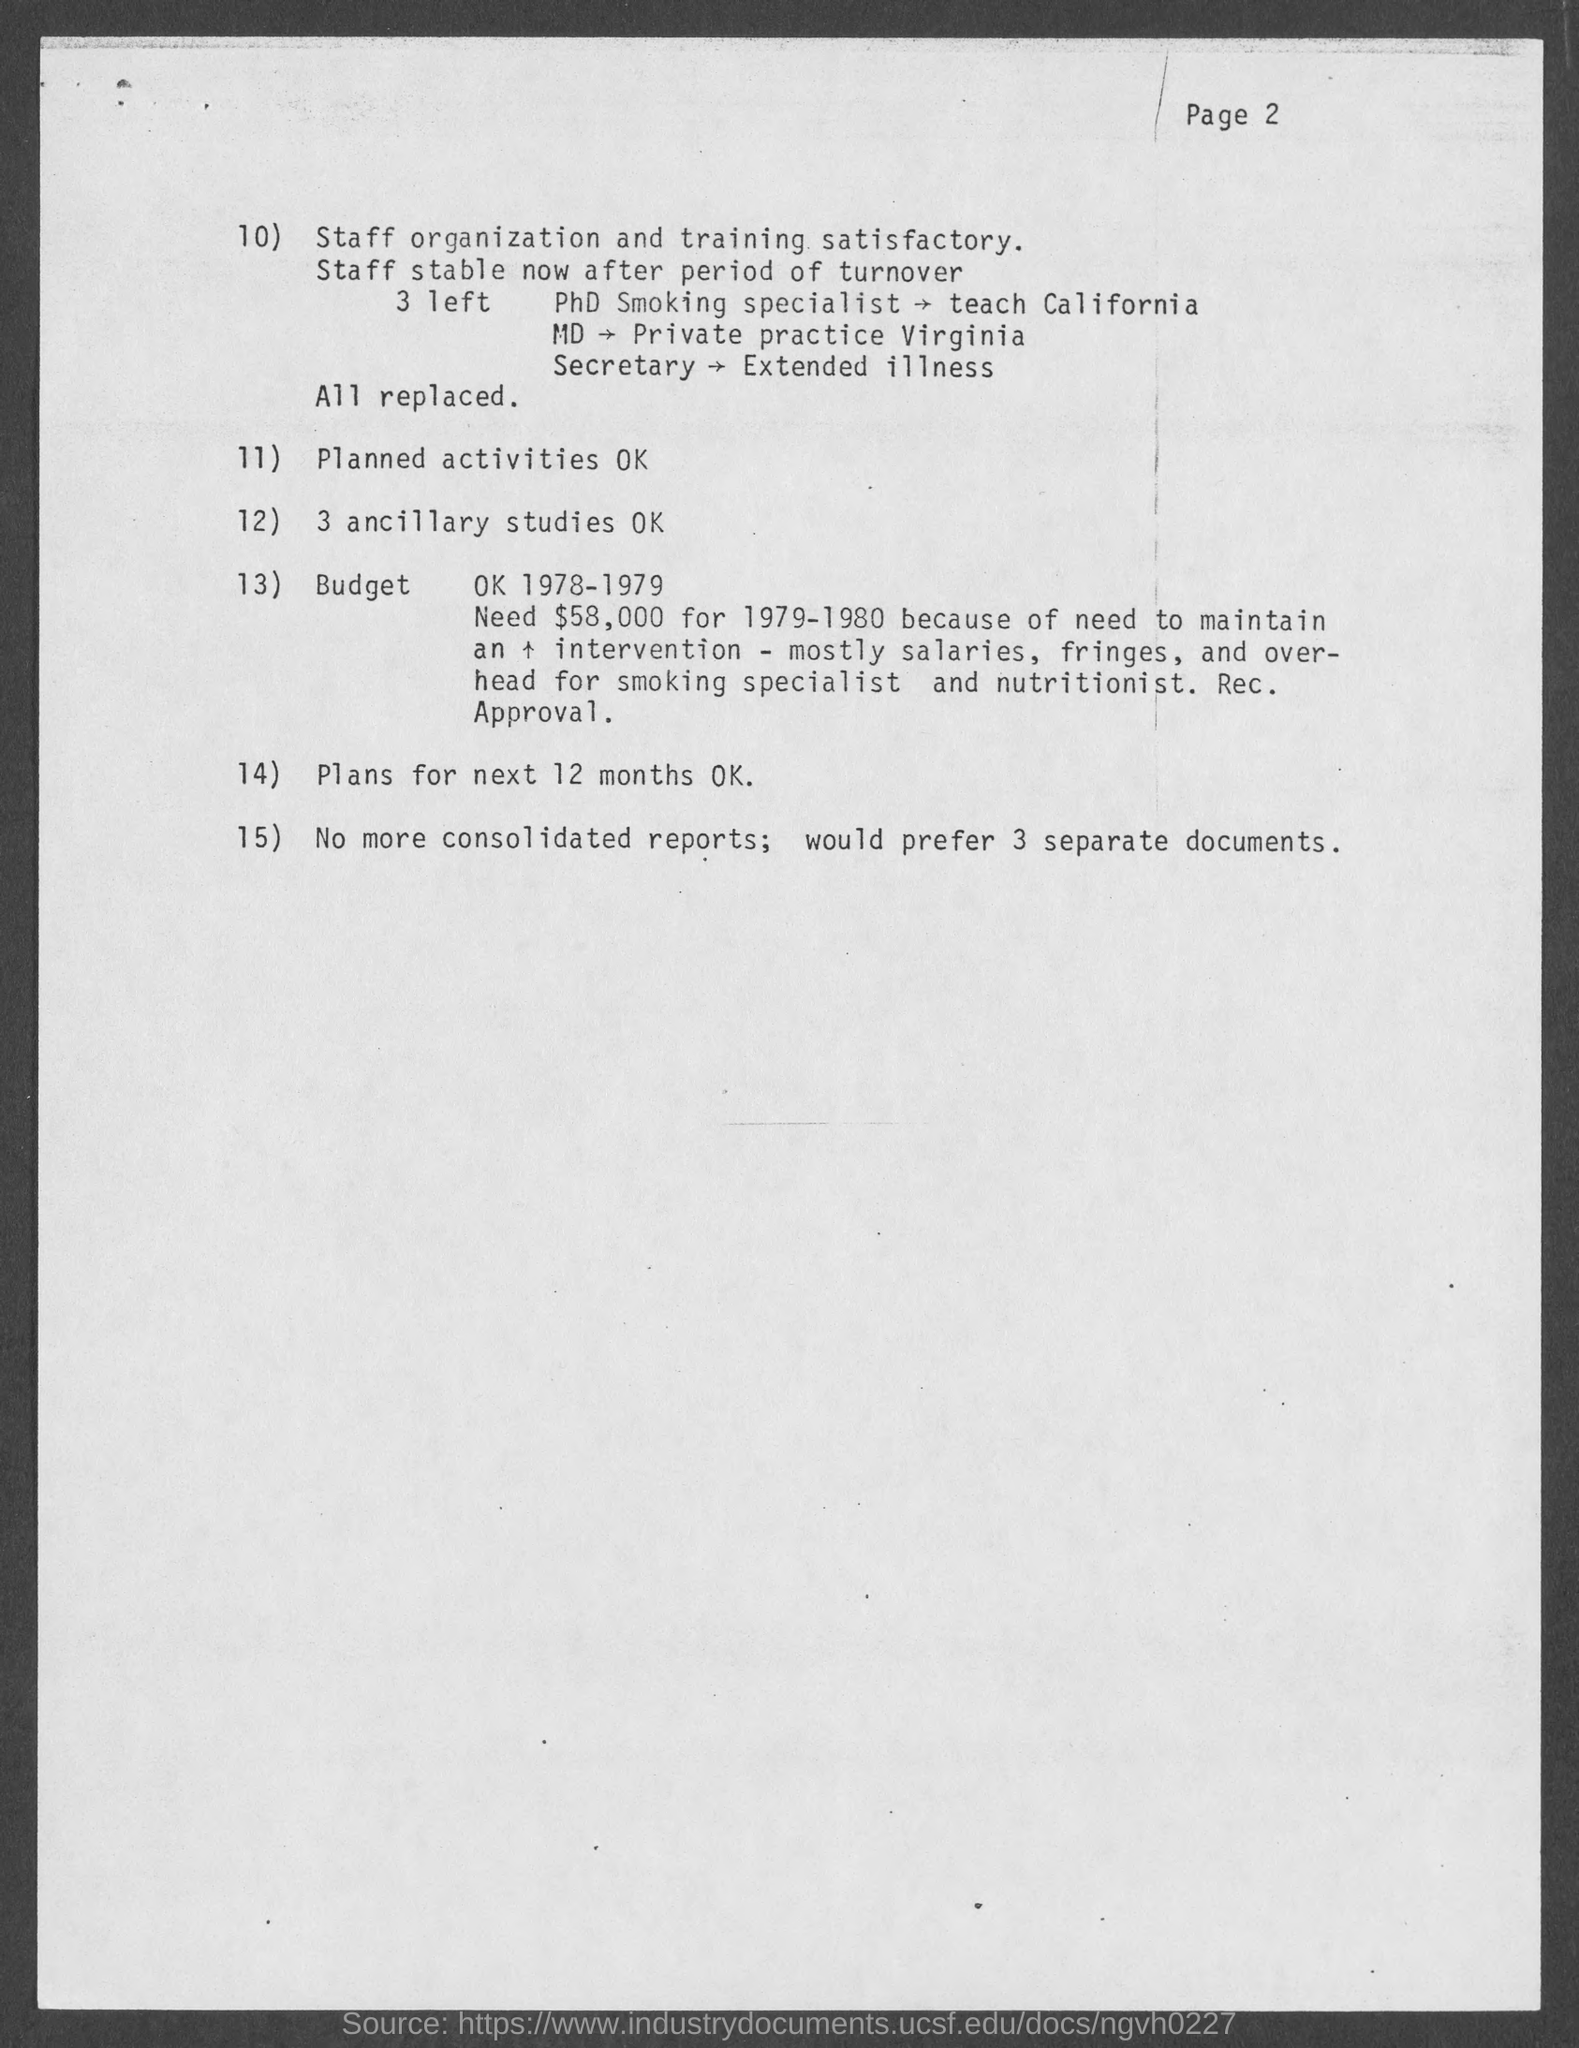Highlight a few significant elements in this photo. The secretary left due to an extended illness. The document states that a plan is needed for 12 months. 